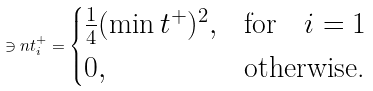Convert formula to latex. <formula><loc_0><loc_0><loc_500><loc_500>\ni n t ^ { + } _ { i } = \begin{cases} \frac { 1 } { 4 } ( \min t ^ { + } ) ^ { 2 } , & \text {for} \quad i = 1 \\ 0 , & \text {otherwise.} \end{cases}</formula> 